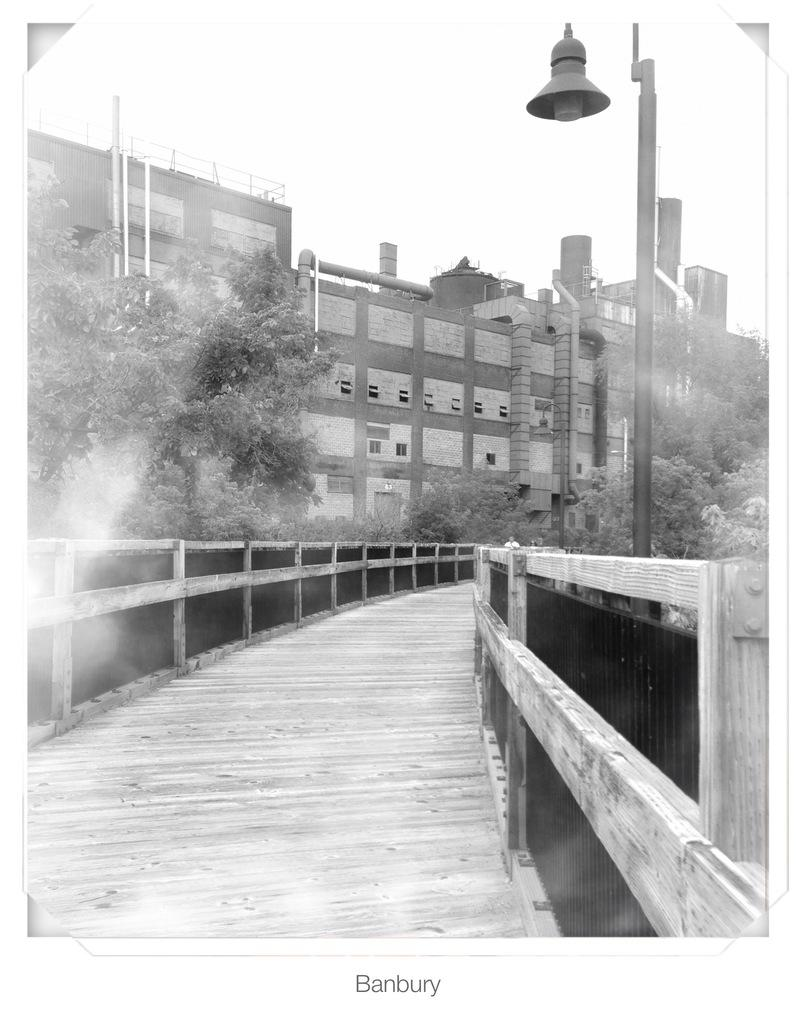What structure is located at the bottom of the image? There is a bridge at the bottom of the image. What can be seen in the background of the image? There are houses and trees in the background of the image. What is located on the right side of the image? There is a pole and light on the right side of the image. Can you see any jellyfish swimming near the bridge in the image? There are no jellyfish present in the image; it features a bridge, houses, trees, and a pole with a light. Is there a pocket visible in the image? There is no pocket present in the image. 